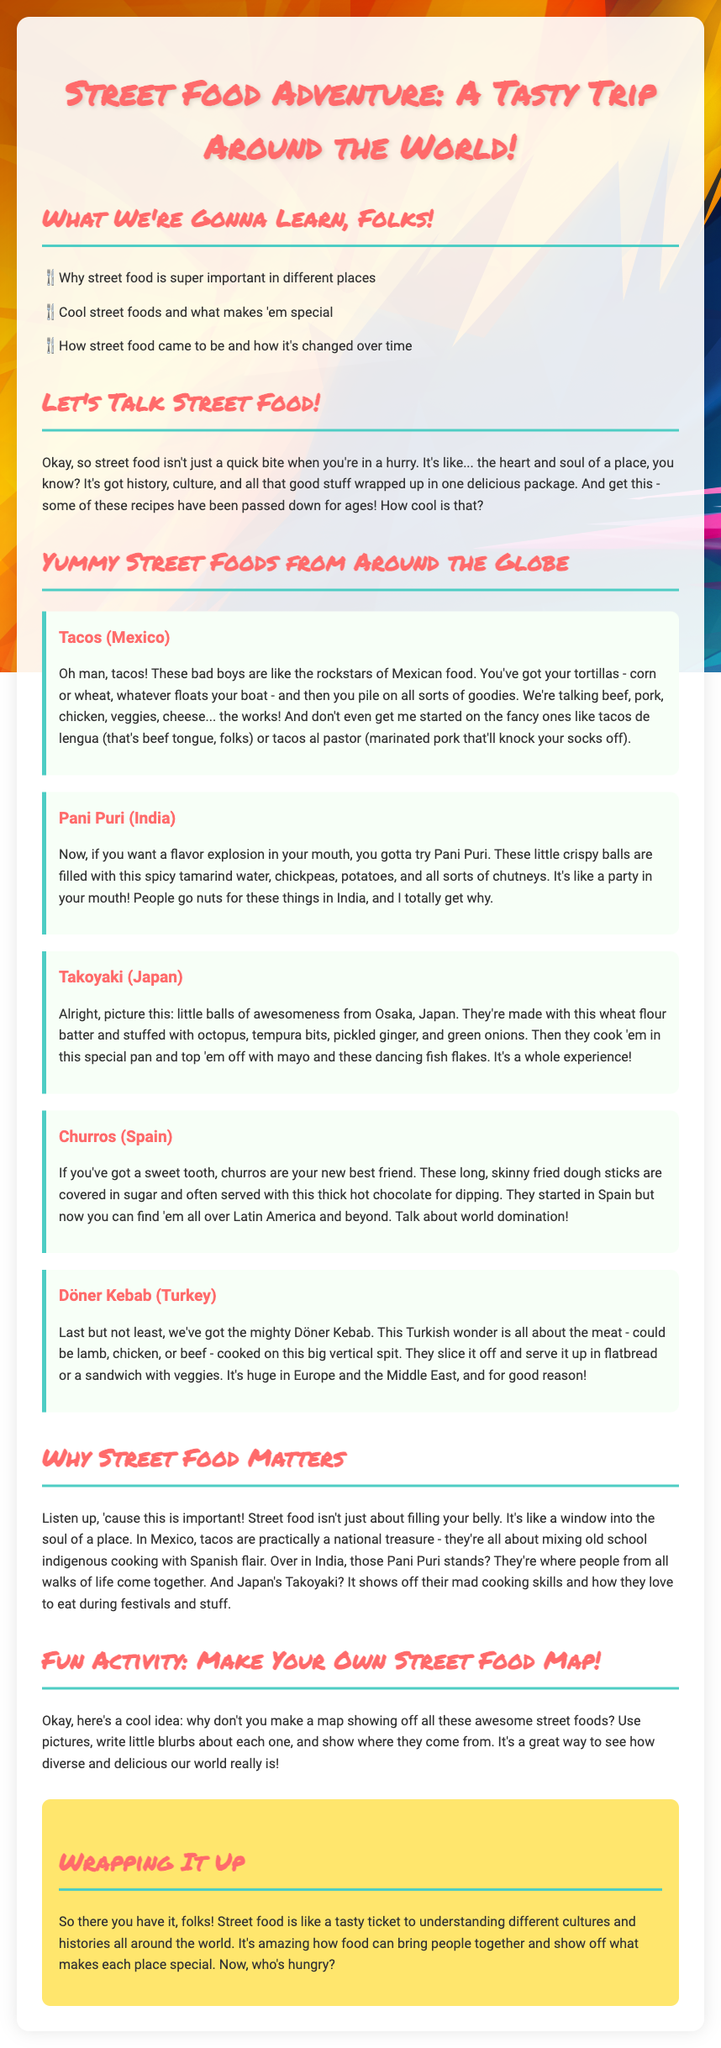What is the title of the lesson plan? The title of the lesson plan is displayed at the top of the document.
Answer: Street Food Adventure: A Tasty Trip Around the World! What are we going to learn? The document lists several learning objectives related to street food.
Answer: Why street food is super important in different places Which street food is from Mexico? The document provides examples of street foods and their origins.
Answer: Tacos What cooking technique is used for Takoyaki? The document describes how Takoyaki is made and cooked.
Answer: Cooked in a special pan What is a fun activity suggested in the lesson plan? The activity encourages students to engage with the subject matter creatively.
Answer: Make Your Own Street Food Map! How does street food relate to culture in Mexico? The document explains the cultural significance of street food in various countries.
Answer: A national treasure What type of food are churros? The document categorizes churros as a type of street food.
Answer: Sweet What is the significance of Pani Puri in India? The document highlights the social aspect and importance of Pani Puri.
Answer: People from all walks of life come together Who are the intended readers of the document? The tone and structure of the lesson plan suggest a specific audience.
Answer: Students 